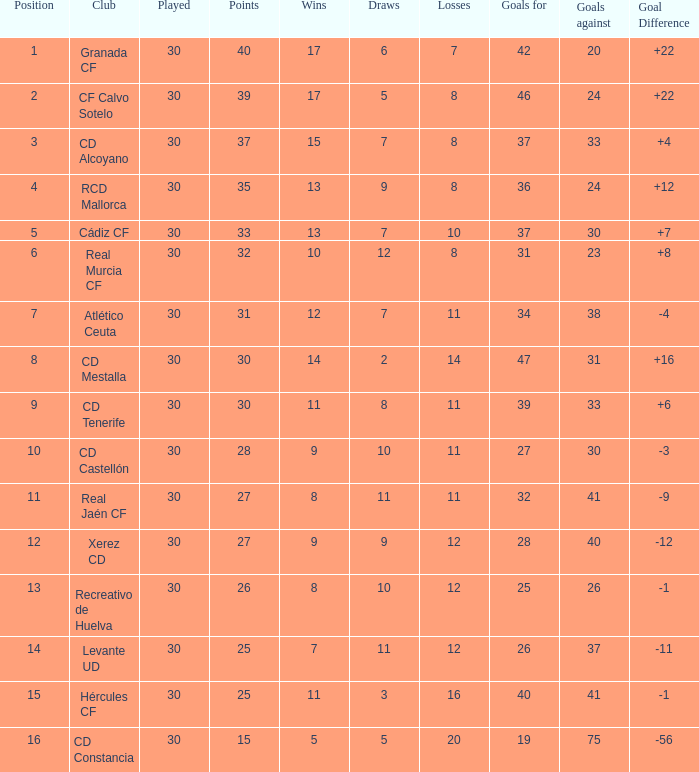Which Played has a Club of atlético ceuta, and less than 11 Losses? None. 